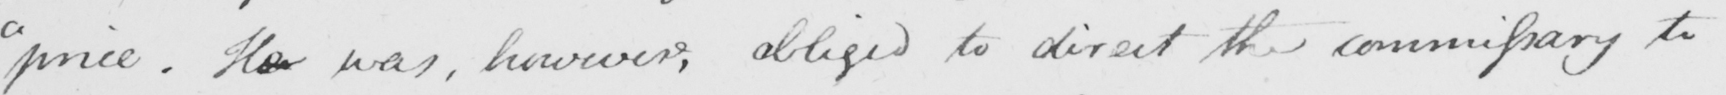What text is written in this handwritten line? " price . He was , however , obliged to direct the commissary to 